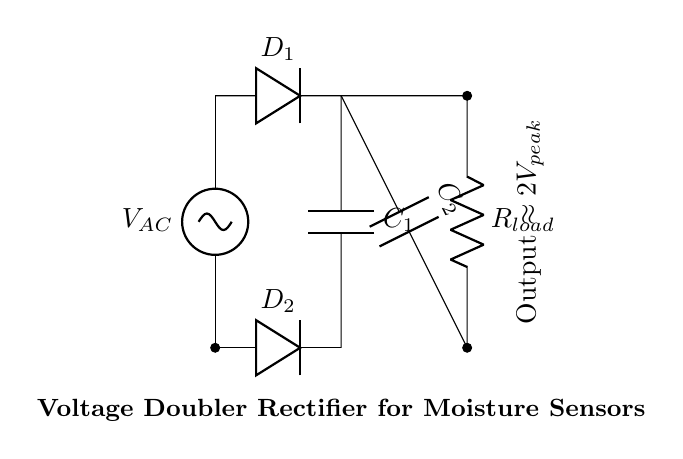What type of circuit is this? The circuit is a voltage doubler rectifier, which is specifically designed to increase the output voltage while converting AC input to DC output. This is indicated by the configuration of the diodes and capacitors.
Answer: Voltage doubler rectifier How many diodes are used in this circuit? The circuit diagram shows two diodes, D1 and D2, which are necessary for the rectification process to allow current flow in one direction while blocking it in the opposite direction.
Answer: Two What is the output voltage of this circuit? The output voltage is approximately two times the peak AC voltage input, as indicated by the label near the output. This is a characteristic feature of a voltage doubler circuit.
Answer: Two times the peak voltage What are the two capacitors labeled in the circuit? The circuit includes two capacitors, C1 and C2, which are used to store charge and help smooth the output voltage after rectification. Their roles are vital for ensuring stable operation of the connected moisture sensors.
Answer: C1 and C2 What does the load resistor represent in this circuit? The load resistor, R_load, represents the resistance of the moisture sensors that the circuit is powering. It plays a crucial role in determining how the current is distributed through the circuit based on the output voltage.
Answer: R_load How does the configuration of the diodes facilitate voltage doubling? The diodes are configured in such a way that they alternate the direction of current flow during different cycles of the AC input, allowing each capacitor to charge to a higher voltage than the AC source alone, thus effectively doubling the output voltage.
Answer: By alternating current flow 